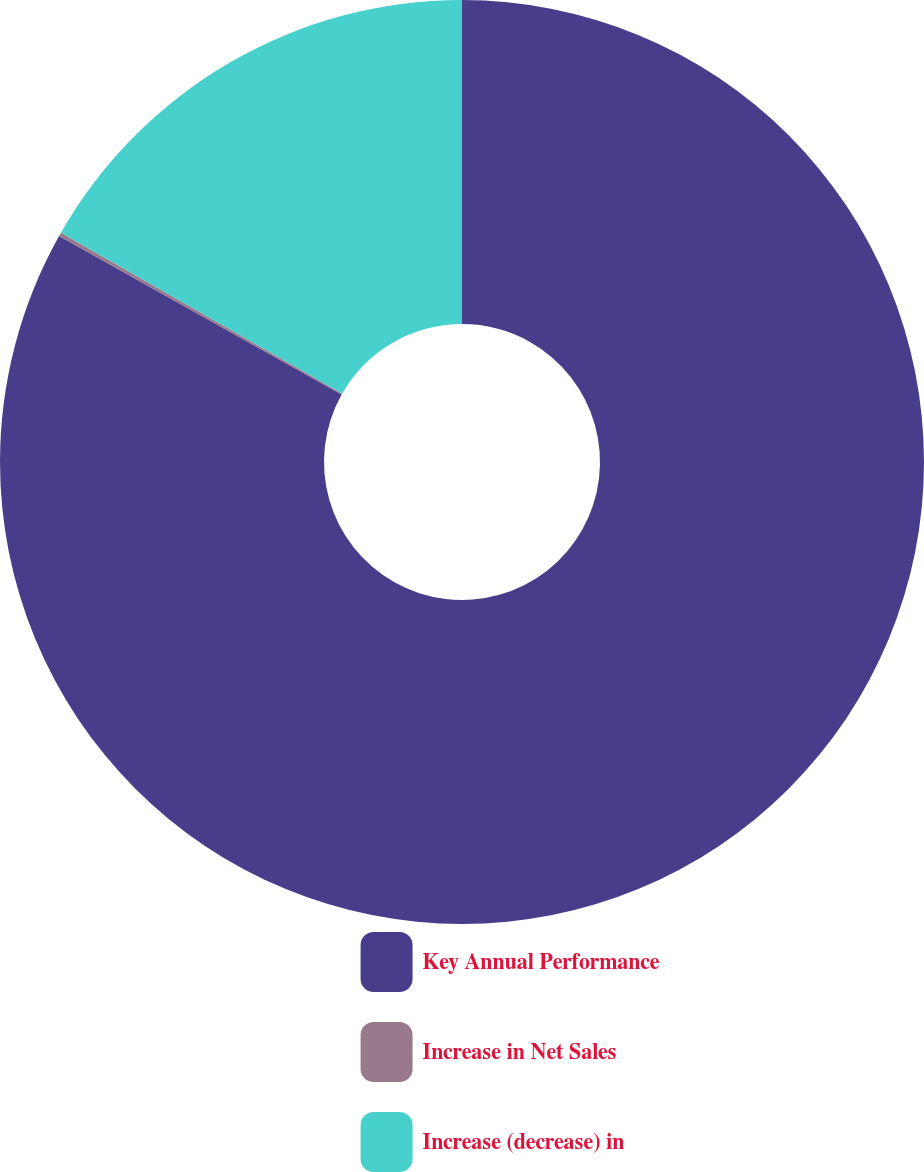Convert chart. <chart><loc_0><loc_0><loc_500><loc_500><pie_chart><fcel>Key Annual Performance<fcel>Increase in Net Sales<fcel>Increase (decrease) in<nl><fcel>83.13%<fcel>0.13%<fcel>16.73%<nl></chart> 